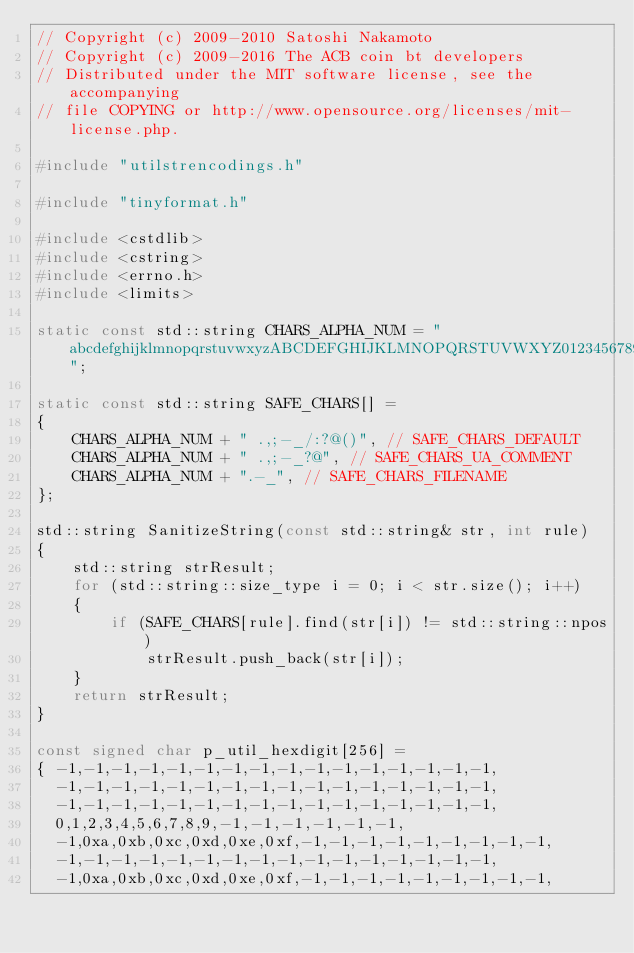<code> <loc_0><loc_0><loc_500><loc_500><_C++_>// Copyright (c) 2009-2010 Satoshi Nakamoto
// Copyright (c) 2009-2016 The ACB coin bt developers
// Distributed under the MIT software license, see the accompanying
// file COPYING or http://www.opensource.org/licenses/mit-license.php.

#include "utilstrencodings.h"

#include "tinyformat.h"

#include <cstdlib>
#include <cstring>
#include <errno.h>
#include <limits>

static const std::string CHARS_ALPHA_NUM = "abcdefghijklmnopqrstuvwxyzABCDEFGHIJKLMNOPQRSTUVWXYZ0123456789";

static const std::string SAFE_CHARS[] =
{
    CHARS_ALPHA_NUM + " .,;-_/:?@()", // SAFE_CHARS_DEFAULT
    CHARS_ALPHA_NUM + " .,;-_?@", // SAFE_CHARS_UA_COMMENT
    CHARS_ALPHA_NUM + ".-_", // SAFE_CHARS_FILENAME
};

std::string SanitizeString(const std::string& str, int rule)
{
    std::string strResult;
    for (std::string::size_type i = 0; i < str.size(); i++)
    {
        if (SAFE_CHARS[rule].find(str[i]) != std::string::npos)
            strResult.push_back(str[i]);
    }
    return strResult;
}

const signed char p_util_hexdigit[256] =
{ -1,-1,-1,-1,-1,-1,-1,-1,-1,-1,-1,-1,-1,-1,-1,-1,
  -1,-1,-1,-1,-1,-1,-1,-1,-1,-1,-1,-1,-1,-1,-1,-1,
  -1,-1,-1,-1,-1,-1,-1,-1,-1,-1,-1,-1,-1,-1,-1,-1,
  0,1,2,3,4,5,6,7,8,9,-1,-1,-1,-1,-1,-1,
  -1,0xa,0xb,0xc,0xd,0xe,0xf,-1,-1,-1,-1,-1,-1,-1,-1,-1,
  -1,-1,-1,-1,-1,-1,-1,-1,-1,-1,-1,-1,-1,-1,-1,-1,
  -1,0xa,0xb,0xc,0xd,0xe,0xf,-1,-1,-1,-1,-1,-1,-1,-1,-1,</code> 